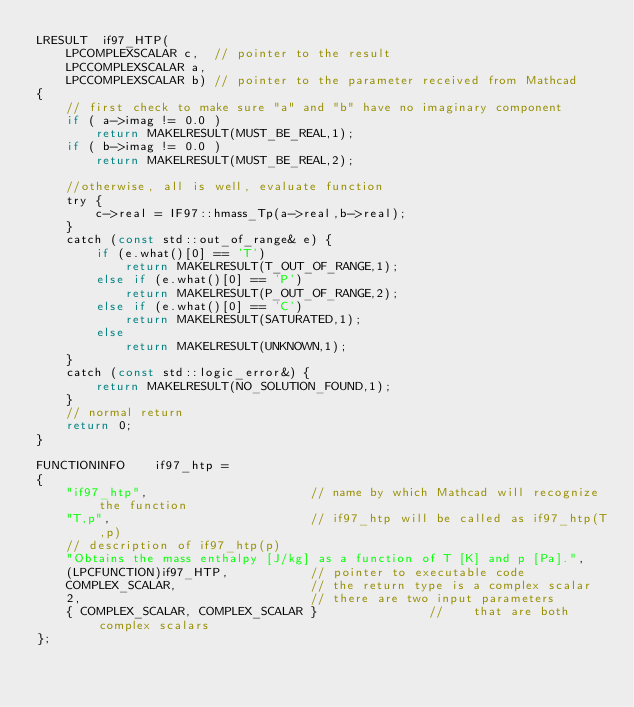Convert code to text. <code><loc_0><loc_0><loc_500><loc_500><_C_>LRESULT  if97_HTP(
    LPCOMPLEXSCALAR c,  // pointer to the result
    LPCCOMPLEXSCALAR a,
    LPCCOMPLEXSCALAR b) // pointer to the parameter received from Mathcad
{  
    // first check to make sure "a" and "b" have no imaginary component
    if ( a->imag != 0.0 )
        return MAKELRESULT(MUST_BE_REAL,1);
    if ( b->imag != 0.0 )
        return MAKELRESULT(MUST_BE_REAL,2);

    //otherwise, all is well, evaluate function
    try {
        c->real = IF97::hmass_Tp(a->real,b->real);
    }
    catch (const std::out_of_range& e) { 
        if (e.what()[0] == 'T') 
            return MAKELRESULT(T_OUT_OF_RANGE,1);
        else if (e.what()[0] == 'P')
            return MAKELRESULT(P_OUT_OF_RANGE,2);
        else if (e.what()[0] == 'C')
            return MAKELRESULT(SATURATED,1);
        else
            return MAKELRESULT(UNKNOWN,1);
    }
    catch (const std::logic_error&) {
        return MAKELRESULT(NO_SOLUTION_FOUND,1);
    }
    // normal return
    return 0;
}

FUNCTIONINFO    if97_htp = 
{
    "if97_htp",                      // name by which Mathcad will recognize the function
    "T,p",                           // if97_htp will be called as if97_htp(T,p)
    // description of if97_htp(p)
    "Obtains the mass enthalpy [J/kg] as a function of T [K] and p [Pa].",
    (LPCFUNCTION)if97_HTP,           // pointer to executable code
    COMPLEX_SCALAR,                  // the return type is a complex scalar
    2,                               // there are two input parameters
    { COMPLEX_SCALAR, COMPLEX_SCALAR }               //    that are both complex scalars
};</code> 